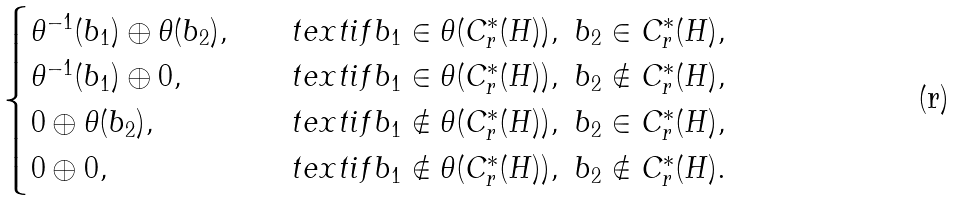Convert formula to latex. <formula><loc_0><loc_0><loc_500><loc_500>\begin{cases} \theta ^ { - 1 } ( b _ { 1 } ) \oplus \theta ( b _ { 2 } ) , & \quad t e x t { i f } b _ { 1 } \in \theta ( C ^ { * } _ { r } ( H ) ) , \ b _ { 2 } \in C ^ { * } _ { r } ( H ) , \\ \theta ^ { - 1 } ( b _ { 1 } ) \oplus 0 , & \quad t e x t { i f } b _ { 1 } \in \theta ( C ^ { * } _ { r } ( H ) ) , \ b _ { 2 } \notin C ^ { * } _ { r } ( H ) , \\ 0 \oplus \theta ( b _ { 2 } ) , & \quad t e x t { i f } b _ { 1 } \notin \theta ( C ^ { * } _ { r } ( H ) ) , \ b _ { 2 } \in C ^ { * } _ { r } ( H ) , \\ 0 \oplus 0 , & \quad t e x t { i f } b _ { 1 } \notin \theta ( C ^ { * } _ { r } ( H ) ) , \ b _ { 2 } \notin C ^ { * } _ { r } ( H ) . \end{cases}</formula> 